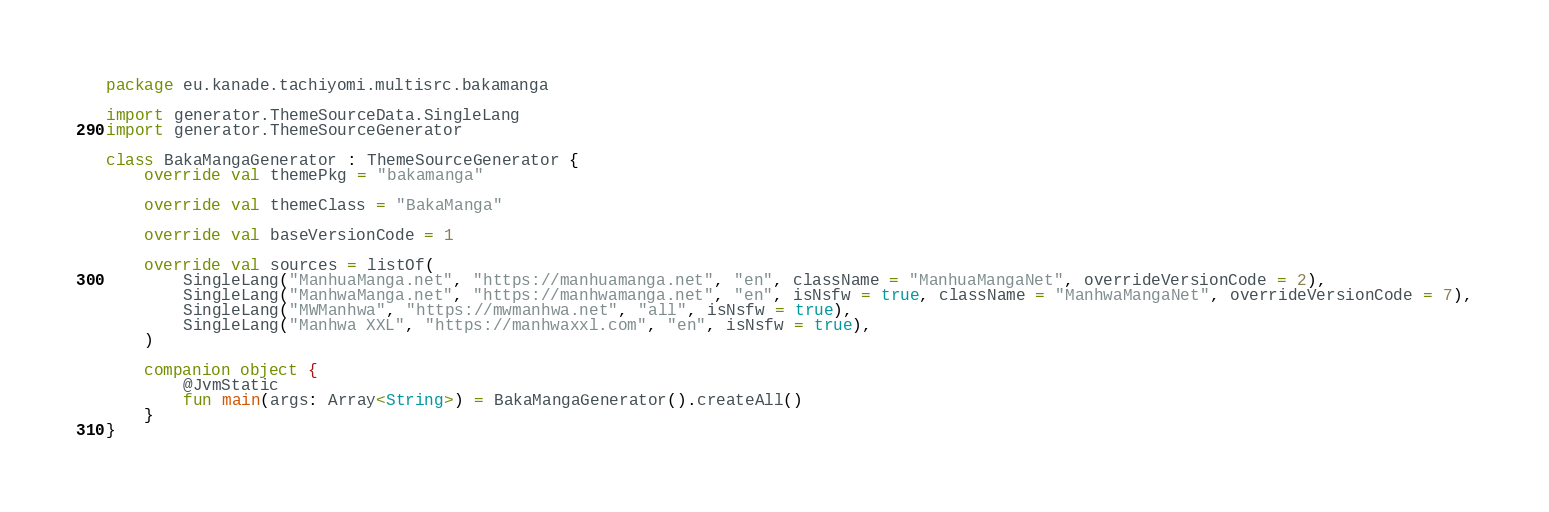Convert code to text. <code><loc_0><loc_0><loc_500><loc_500><_Kotlin_>package eu.kanade.tachiyomi.multisrc.bakamanga

import generator.ThemeSourceData.SingleLang
import generator.ThemeSourceGenerator

class BakaMangaGenerator : ThemeSourceGenerator {
    override val themePkg = "bakamanga"

    override val themeClass = "BakaManga"

    override val baseVersionCode = 1

    override val sources = listOf(
        SingleLang("ManhuaManga.net", "https://manhuamanga.net", "en", className = "ManhuaMangaNet", overrideVersionCode = 2),
        SingleLang("ManhwaManga.net", "https://manhwamanga.net", "en", isNsfw = true, className = "ManhwaMangaNet", overrideVersionCode = 7),
        SingleLang("MWManhwa", "https://mwmanhwa.net", "all", isNsfw = true),
        SingleLang("Manhwa XXL", "https://manhwaxxl.com", "en", isNsfw = true),
    )

    companion object {
        @JvmStatic
        fun main(args: Array<String>) = BakaMangaGenerator().createAll()
    }
}
</code> 